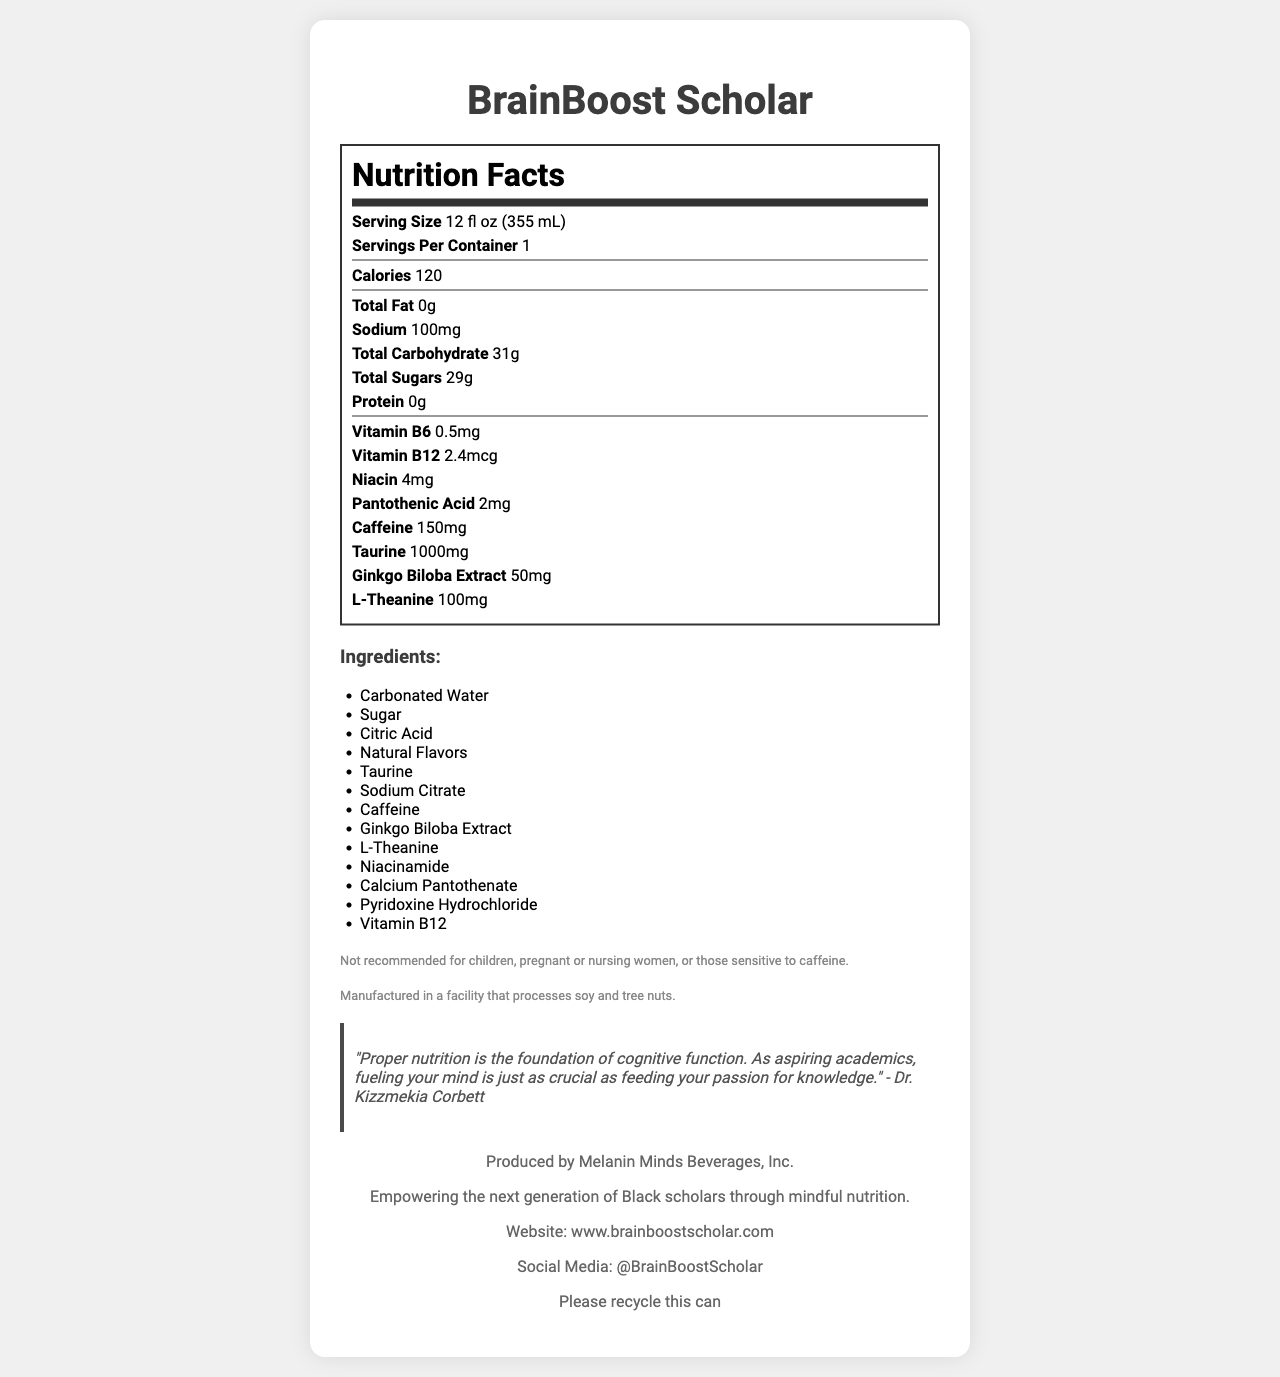what is the serving size for BrainBoost Scholar? The serving size is listed directly under the nutrition facts header as "Serving Size 12 fl oz (355 mL)".
Answer: 12 fl oz (355 mL) how many calories are there in one serving of BrainBoost Scholar? The number of calories per serving is stated as "Calories 120" in the nutrition facts section.
Answer: 120 what are the ingredients in BrainBoost Scholar? The list of ingredients is provided in a section labeled "Ingredients" with each ingredient listed in a bullet point format.
Answer: Carbonated Water, Sugar, Citric Acid, Natural Flavors, Taurine, Sodium Citrate, Caffeine, Ginkgo Biloba Extract, L-Theanine, Niacinamide, Calcium Pantothenate, Pyridoxine Hydrochloride, Vitamin B12. how much caffeine does one serving of BrainBoost Scholar contain? The amount of caffeine is mentioned under the nutrition facts as "Caffeine 150mg".
Answer: 150mg what is the sodium content in one serving of BrainBoost Scholar? The sodium content is listed as "Sodium 100mg" in the nutrition facts section.
Answer: 100mg which of the following vitamins are present in BrainBoost Scholar? A. Vitamin C B. Vitamin D C. Vitamin B6 D. Vitamin E The vitamins listed under the nutrition facts include Vitamin B6 as "Vitamin B6 0.5mg".
Answer: C. Vitamin B6 what is the source of the quote featured in the document? The quote is attributed to Dr. Kizzmekia Corbett, as indicated in the section with the quotation marks.
Answer: Dr. Kizzmekia Corbett how many types of nutritional additives are specifically listed in the nutrition facts of BrainBoost Scholar? A. 3 B. 4 C. 5 D. 6 The nutritional additives include Vitamin B6, Vitamin B12, Niacin, Pantothenic Acid, Taurine, and Ginkgo Biloba Extract, making a total of six.
Answer: D. 6 was BrainBoost Scholar recommended for children? The document includes a disclaimer stating "Not recommended for children, pregnant or nursing women, or those sensitive to caffeine."
Answer: No summarize the main message of BrainBoost Scholar's nutrition document. The document combines the nutritional details of an academic-targeted energy drink with a motivational quote and company information, highlighting the importance of nutrition for cognitive function and academic performance while promoting a mission to empower Black scholars.
Answer: The BrainBoost Scholar document provides detailed nutrition facts for an energy drink marketed towards aspiring academics, featuring a quote from Dr. Kizzmekia Corbett about the importance of proper nutrition. It lists the ingredients and includes disclaimers about who should avoid the product. The document is produced by Melanin Minds Beverages, Inc., promoting mindful nutrition for Black scholars. where is Melanin Minds Beverages, Inc. located? The document mentions Melanin Minds Beverages, Inc. as the producer but does not provide a location.
Answer: Not enough information 